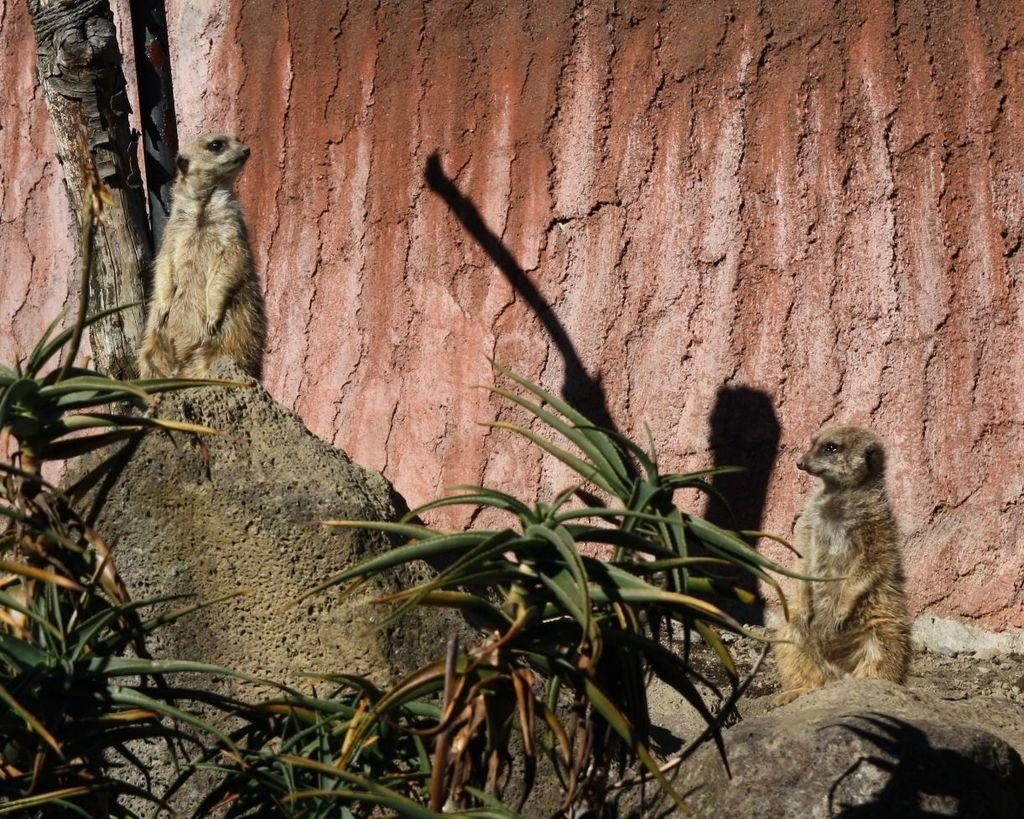What type of vegetation is present in the image? There are plants with leaves in the image. Can you describe the larger plant in the image? There is a tree in the image. How many animals can be seen in the image? There are two animals in the image. What is the background of the image made of? There is a wall in the image. How many ants are crawling on the tree in the image? There are no ants present in the image; it only features plants, a tree, animals, and a wall. Who is the expert on the plants in the image? There is no expert mentioned or implied in the image; it simply shows plants, a tree, animals, and a wall. 